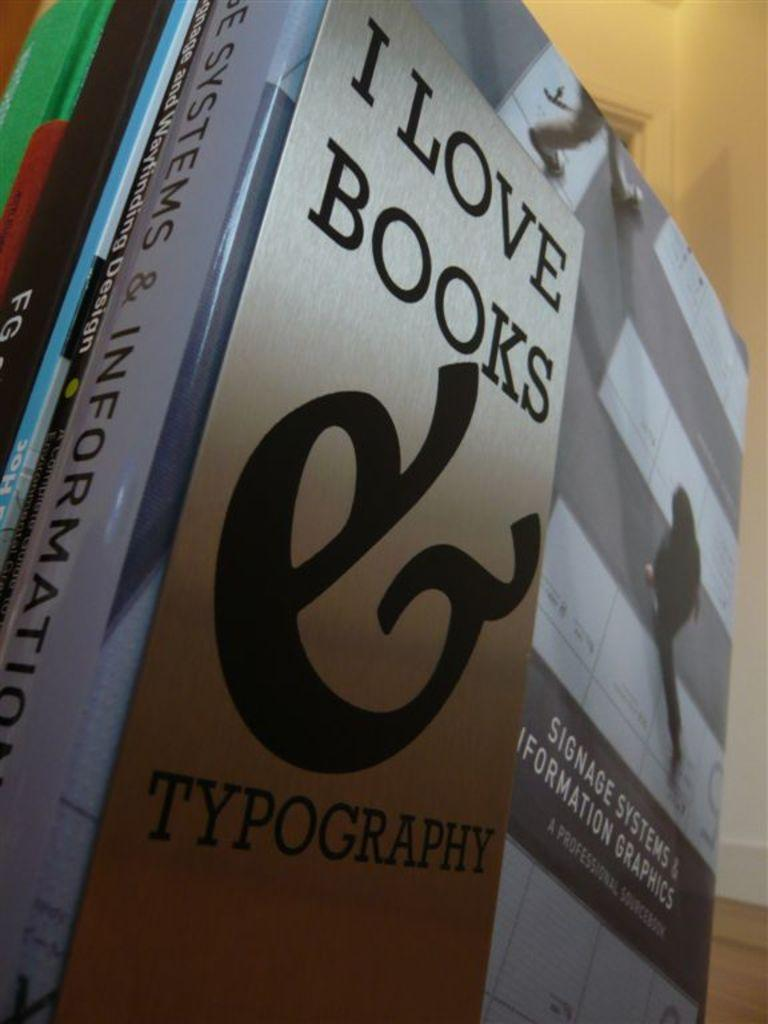<image>
Relay a brief, clear account of the picture shown. I love books typography book in a room on the floor 